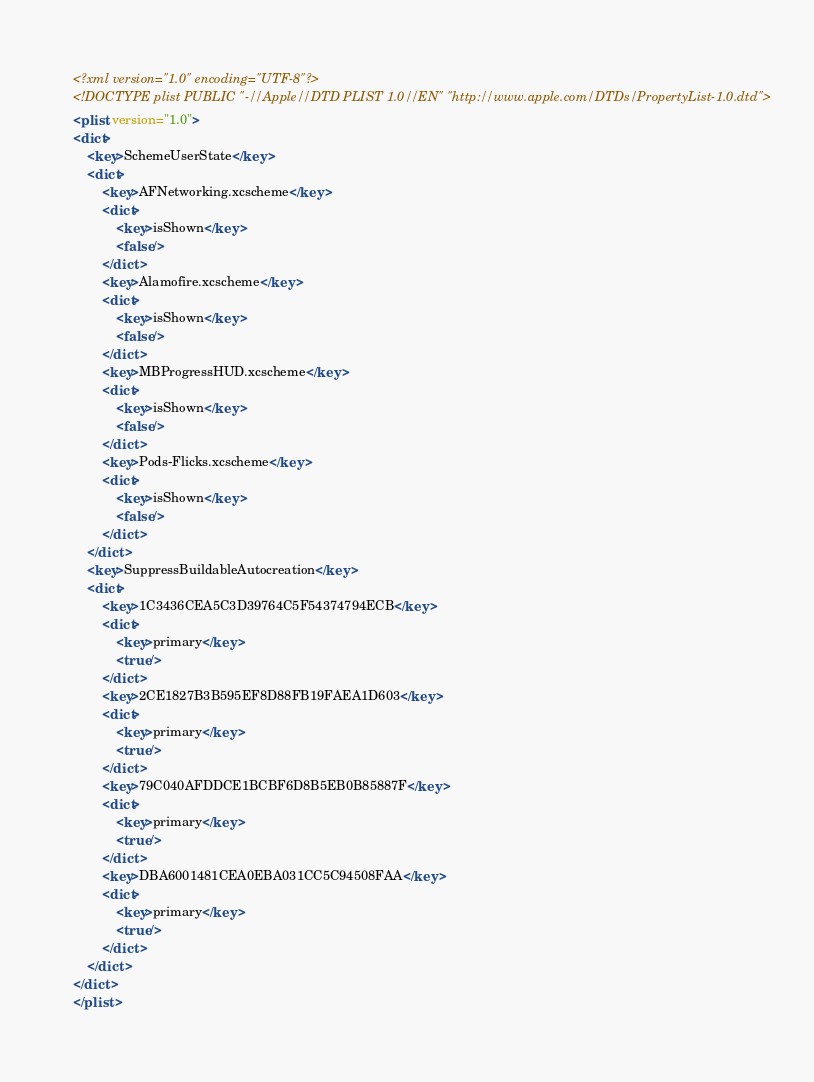Convert code to text. <code><loc_0><loc_0><loc_500><loc_500><_XML_><?xml version="1.0" encoding="UTF-8"?>
<!DOCTYPE plist PUBLIC "-//Apple//DTD PLIST 1.0//EN" "http://www.apple.com/DTDs/PropertyList-1.0.dtd">
<plist version="1.0">
<dict>
	<key>SchemeUserState</key>
	<dict>
		<key>AFNetworking.xcscheme</key>
		<dict>
			<key>isShown</key>
			<false/>
		</dict>
		<key>Alamofire.xcscheme</key>
		<dict>
			<key>isShown</key>
			<false/>
		</dict>
		<key>MBProgressHUD.xcscheme</key>
		<dict>
			<key>isShown</key>
			<false/>
		</dict>
		<key>Pods-Flicks.xcscheme</key>
		<dict>
			<key>isShown</key>
			<false/>
		</dict>
	</dict>
	<key>SuppressBuildableAutocreation</key>
	<dict>
		<key>1C3436CEA5C3D39764C5F54374794ECB</key>
		<dict>
			<key>primary</key>
			<true/>
		</dict>
		<key>2CE1827B3B595EF8D88FB19FAEA1D603</key>
		<dict>
			<key>primary</key>
			<true/>
		</dict>
		<key>79C040AFDDCE1BCBF6D8B5EB0B85887F</key>
		<dict>
			<key>primary</key>
			<true/>
		</dict>
		<key>DBA6001481CEA0EBA031CC5C94508FAA</key>
		<dict>
			<key>primary</key>
			<true/>
		</dict>
	</dict>
</dict>
</plist>
</code> 